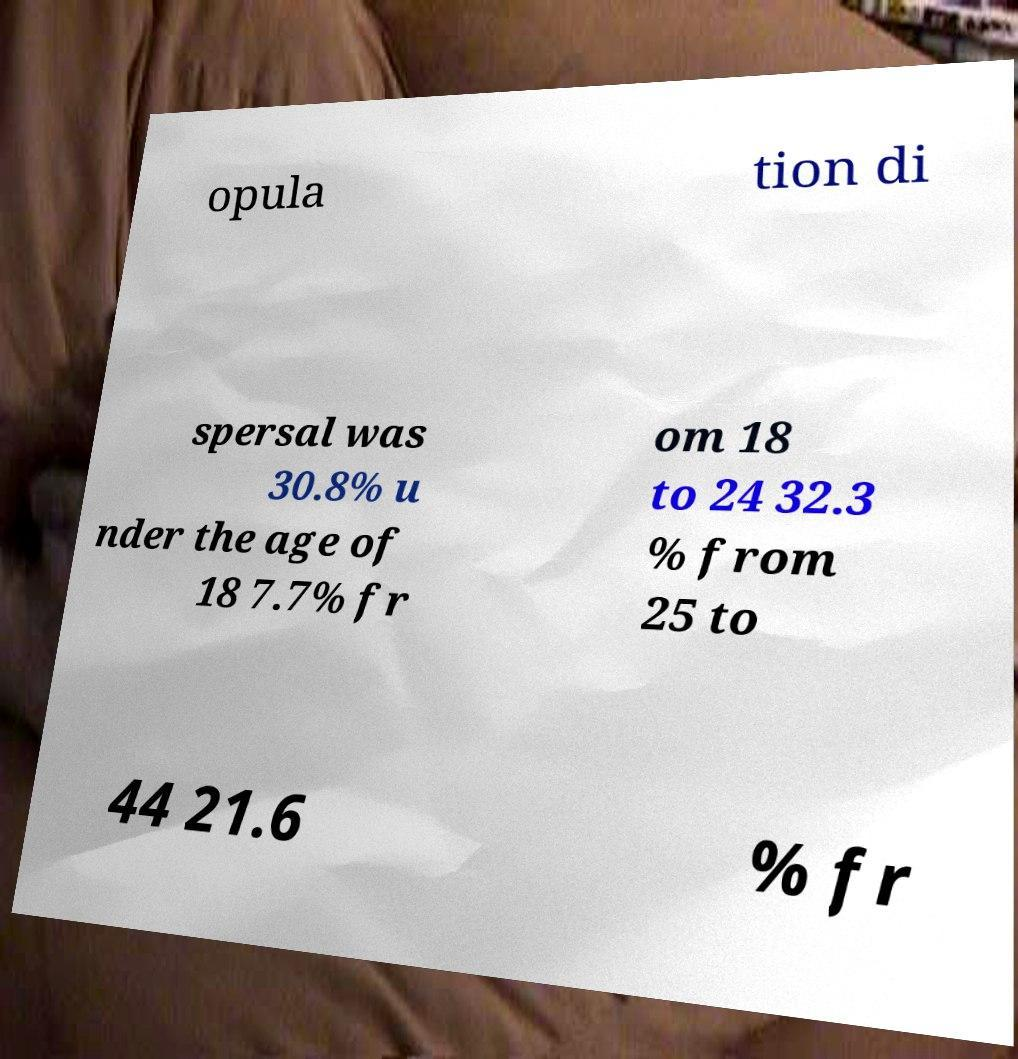Could you extract and type out the text from this image? opula tion di spersal was 30.8% u nder the age of 18 7.7% fr om 18 to 24 32.3 % from 25 to 44 21.6 % fr 